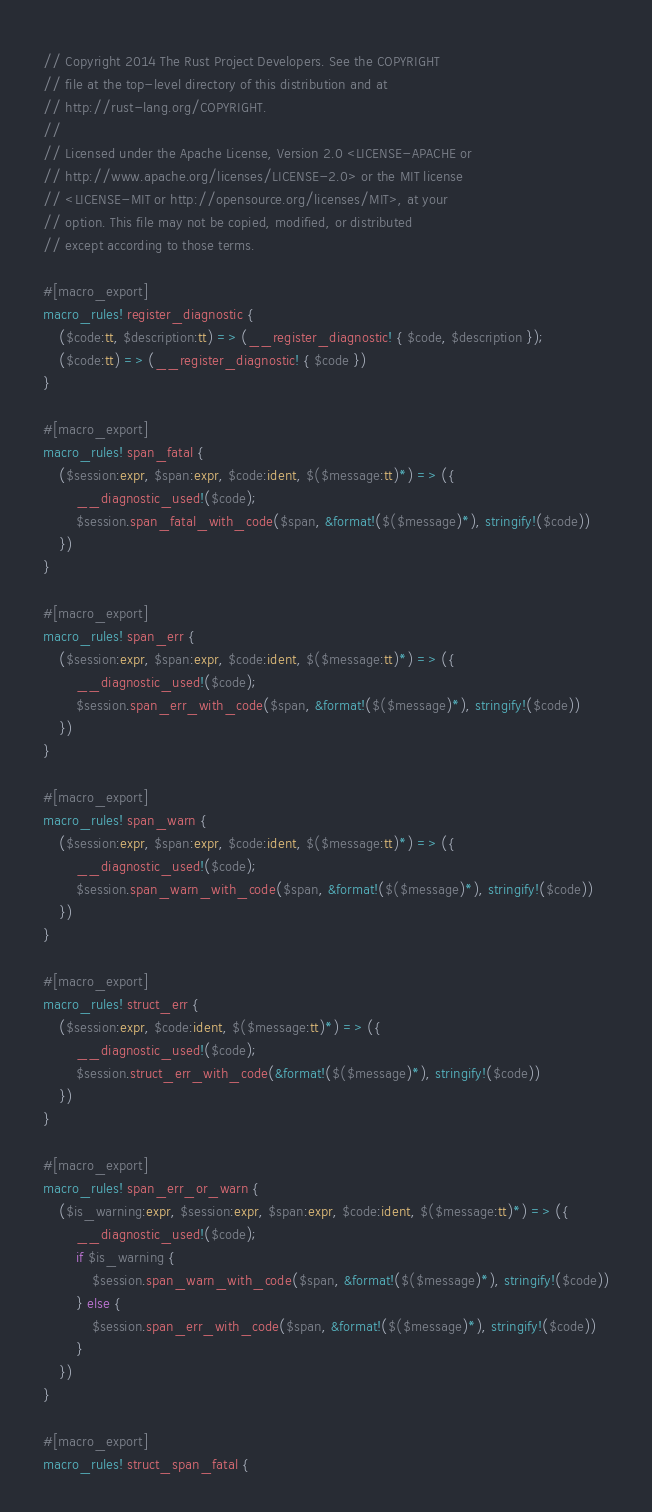Convert code to text. <code><loc_0><loc_0><loc_500><loc_500><_Rust_>// Copyright 2014 The Rust Project Developers. See the COPYRIGHT
// file at the top-level directory of this distribution and at
// http://rust-lang.org/COPYRIGHT.
//
// Licensed under the Apache License, Version 2.0 <LICENSE-APACHE or
// http://www.apache.org/licenses/LICENSE-2.0> or the MIT license
// <LICENSE-MIT or http://opensource.org/licenses/MIT>, at your
// option. This file may not be copied, modified, or distributed
// except according to those terms.

#[macro_export]
macro_rules! register_diagnostic {
    ($code:tt, $description:tt) => (__register_diagnostic! { $code, $description });
    ($code:tt) => (__register_diagnostic! { $code })
}

#[macro_export]
macro_rules! span_fatal {
    ($session:expr, $span:expr, $code:ident, $($message:tt)*) => ({
        __diagnostic_used!($code);
        $session.span_fatal_with_code($span, &format!($($message)*), stringify!($code))
    })
}

#[macro_export]
macro_rules! span_err {
    ($session:expr, $span:expr, $code:ident, $($message:tt)*) => ({
        __diagnostic_used!($code);
        $session.span_err_with_code($span, &format!($($message)*), stringify!($code))
    })
}

#[macro_export]
macro_rules! span_warn {
    ($session:expr, $span:expr, $code:ident, $($message:tt)*) => ({
        __diagnostic_used!($code);
        $session.span_warn_with_code($span, &format!($($message)*), stringify!($code))
    })
}

#[macro_export]
macro_rules! struct_err {
    ($session:expr, $code:ident, $($message:tt)*) => ({
        __diagnostic_used!($code);
        $session.struct_err_with_code(&format!($($message)*), stringify!($code))
    })
}

#[macro_export]
macro_rules! span_err_or_warn {
    ($is_warning:expr, $session:expr, $span:expr, $code:ident, $($message:tt)*) => ({
        __diagnostic_used!($code);
        if $is_warning {
            $session.span_warn_with_code($span, &format!($($message)*), stringify!($code))
        } else {
            $session.span_err_with_code($span, &format!($($message)*), stringify!($code))
        }
    })
}

#[macro_export]
macro_rules! struct_span_fatal {</code> 